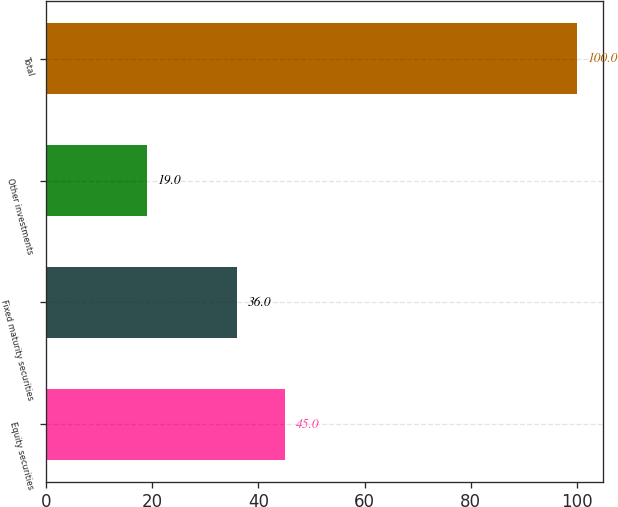Convert chart. <chart><loc_0><loc_0><loc_500><loc_500><bar_chart><fcel>Equity securities<fcel>Fixed maturity securities<fcel>Other investments<fcel>Total<nl><fcel>45<fcel>36<fcel>19<fcel>100<nl></chart> 